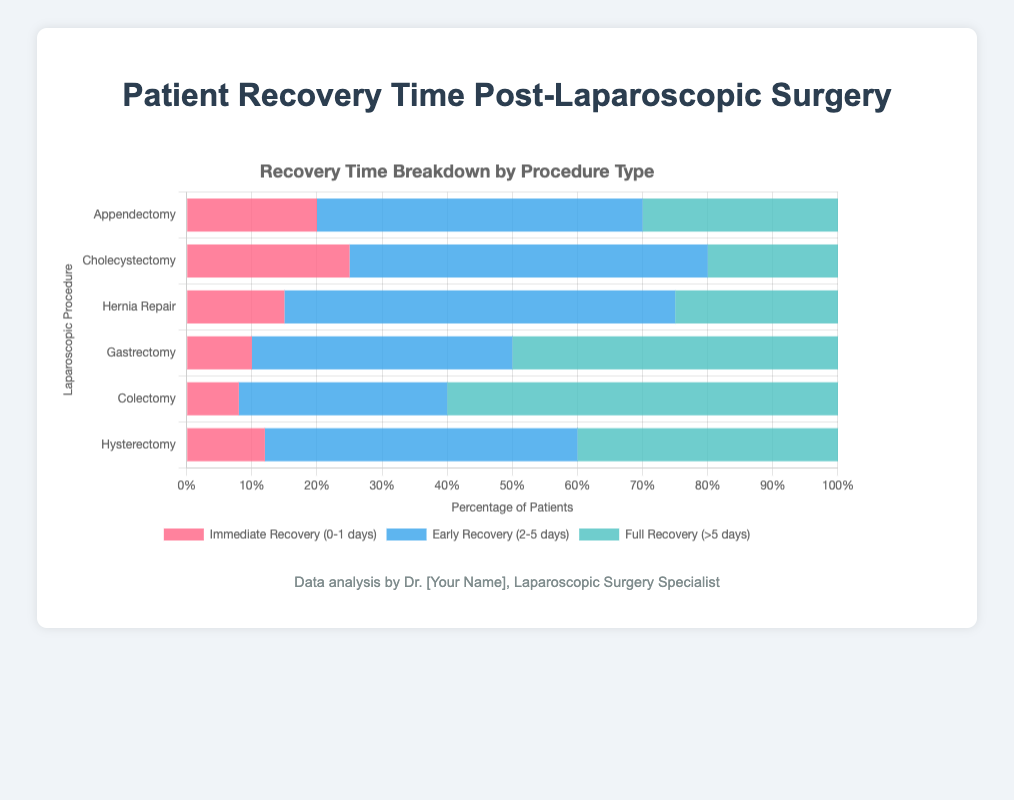Which procedure has the highest percentage of patients in the Immediate Recovery category (0-1 days)? To determine this, we look at the Immediate Recovery percentages for all procedures. Appendectomy has 20%; Cholecystectomy has 25%; Hernia Repair has 15%; Gastrectomy has 10%; Colectomy has 8%; Hysterectomy has 12%. The highest percentage is 25% for Cholecystectomy.
Answer: Cholecystectomy Which procedure has the largest proportion of patients needing more than 5 days for full recovery? To find this, we review the Full Recovery (>5 days) percentages. Appendectomy has 30%, Cholecystectomy has 20%, Hernia Repair has 25%, Gastrectomy has 50%, Colectomy has 60%, Hysterectomy has 40%. The highest percentage is 60%, which is for Colectomy.
Answer: Colectomy How much higher is the percentage of patients recovering in 2-5 days for Hernia Repair compared to Appendectomy? The Early Recovery percentage for Hernia Repair is 60%, and for Appendectomy, it is 50%. The difference is calculated as 60% - 50% = 10%.
Answer: 10% Rank the procedures by the percentage of patients in Immediate Recovery from highest to lowest. From the data, Cholecystectomy has 25%, Appendectomy 20%, Hernia Repair 15%, Hysterectomy 12%, Gastrectomy 10%, and Colectomy 8%. Thus, the ranked order from highest to lowest is: Cholecystectomy, Appendectomy, Hernia Repair, Hysterectomy, Gastrectomy, Colectomy.
Answer: Cholecystectomy, Appendectomy, Hernia Repair, Hysterectomy, Gastrectomy, Colectomy Which procedures have an equal percentage of patients fully recovering in more than 5 days? Looking at the Full Recovery percentages, we find that Hernia Repair has 25%, and none of the other procedures match this percentage exactly. Thus, no procedures have an equal percentage for Full Recovery.
Answer: None What is the average percentage of patients in Immediate Recovery across all procedures? The Immediate Recovery percentages are: Appendectomy 20%, Cholecystectomy 25%, Hernia Repair 15%, Gastrectomy 10%, Colectomy 8%, and Hysterectomy 12%. The average is calculated as (20 + 25 + 15 + 10 + 8 + 12) / 6 = 15%.
Answer: 15% Compare the percentage of Early Recovery patients between Colectomy and Gastrectomy. Which is higher and by how much? The Early Recovery percentage for Colectomy is 32%, and for Gastrectomy, it is 40%. Gastrectomy has a higher percentage. The difference is 40% - 32% = 8%.
Answer: Gastrectomy, 8% higher Which procedure has the lowest percentage of patients in Early Recovery (2-5 days)? The Early Recovery percentages are: Appendectomy 50%, Cholecystectomy 55%, Hernia Repair 60%, Gastrectomy 40%, Colectomy 32%, and Hysterectomy 48%. The lowest percentage is 32% for Colectomy.
Answer: Colectomy What is the total percentage of patients recovering within 5 days for Hysterectomy (combining Immediate and Early Recovery)? For Hysterectomy, the Immediate Recovery percentage is 12%, and the Early Recovery percentage is 48%. Adding these together gives 12% + 48% = 60%.
Answer: 60% 